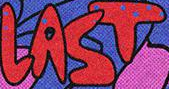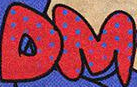What words are shown in these images in order, separated by a semicolon? LAST; DM 